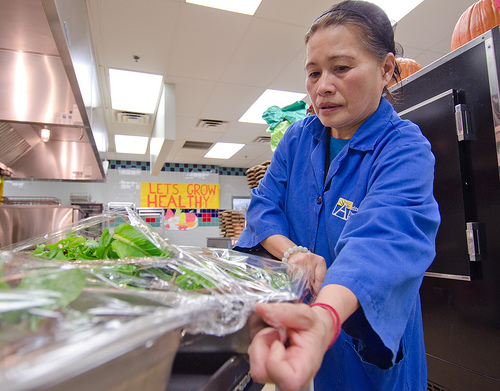<image>
Is the pumpkin next to the head? No. The pumpkin is not positioned next to the head. They are located in different areas of the scene. 